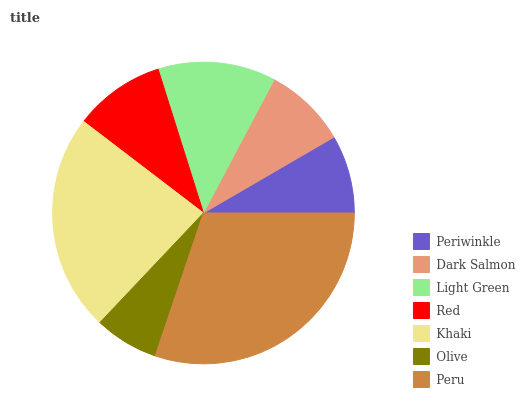Is Olive the minimum?
Answer yes or no. Yes. Is Peru the maximum?
Answer yes or no. Yes. Is Dark Salmon the minimum?
Answer yes or no. No. Is Dark Salmon the maximum?
Answer yes or no. No. Is Dark Salmon greater than Periwinkle?
Answer yes or no. Yes. Is Periwinkle less than Dark Salmon?
Answer yes or no. Yes. Is Periwinkle greater than Dark Salmon?
Answer yes or no. No. Is Dark Salmon less than Periwinkle?
Answer yes or no. No. Is Red the high median?
Answer yes or no. Yes. Is Red the low median?
Answer yes or no. Yes. Is Periwinkle the high median?
Answer yes or no. No. Is Light Green the low median?
Answer yes or no. No. 